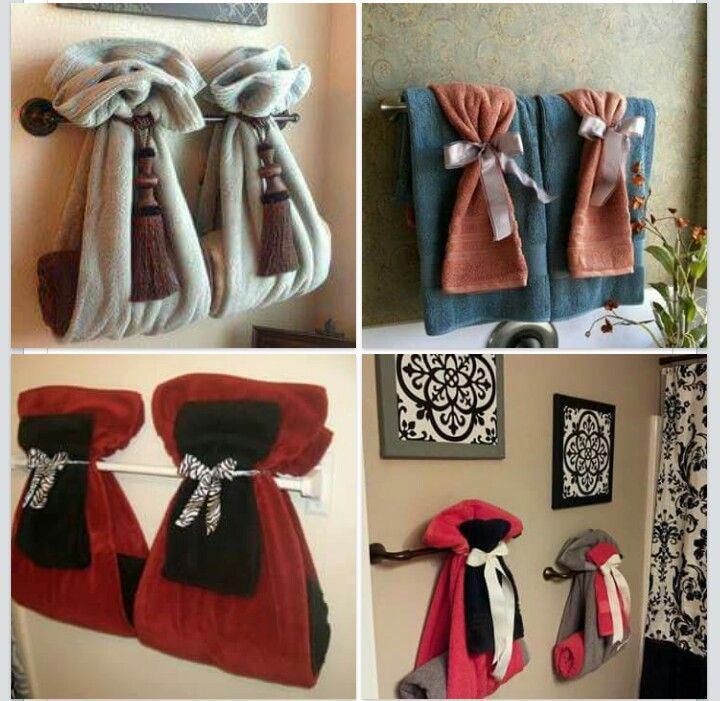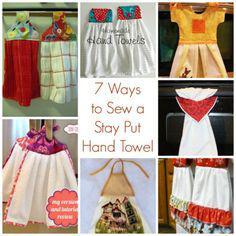The first image is the image on the left, the second image is the image on the right. Considering the images on both sides, is "Each image shows multiple hand towel decor ideas." valid? Answer yes or no. Yes. 